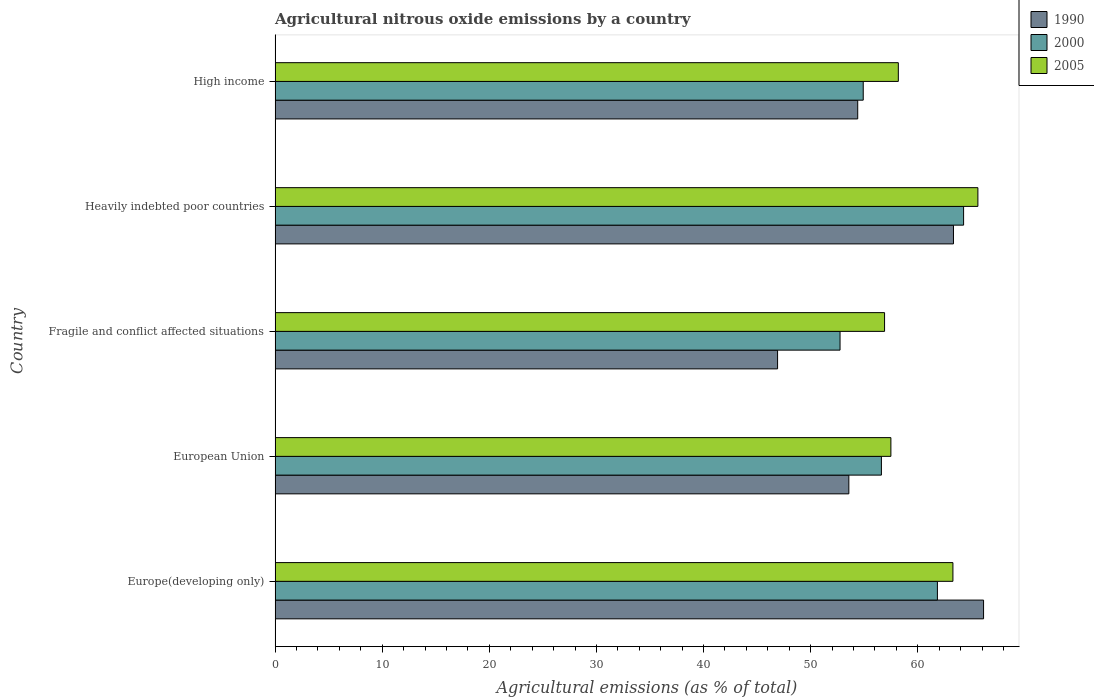Are the number of bars on each tick of the Y-axis equal?
Give a very brief answer. Yes. How many bars are there on the 1st tick from the bottom?
Make the answer very short. 3. What is the label of the 1st group of bars from the top?
Ensure brevity in your answer.  High income. What is the amount of agricultural nitrous oxide emitted in 2000 in Heavily indebted poor countries?
Keep it short and to the point. 64.27. Across all countries, what is the maximum amount of agricultural nitrous oxide emitted in 1990?
Provide a short and direct response. 66.14. Across all countries, what is the minimum amount of agricultural nitrous oxide emitted in 1990?
Offer a terse response. 46.91. In which country was the amount of agricultural nitrous oxide emitted in 2000 maximum?
Give a very brief answer. Heavily indebted poor countries. In which country was the amount of agricultural nitrous oxide emitted in 1990 minimum?
Offer a terse response. Fragile and conflict affected situations. What is the total amount of agricultural nitrous oxide emitted in 2000 in the graph?
Give a very brief answer. 290.35. What is the difference between the amount of agricultural nitrous oxide emitted in 1990 in European Union and that in Fragile and conflict affected situations?
Give a very brief answer. 6.65. What is the difference between the amount of agricultural nitrous oxide emitted in 2005 in Heavily indebted poor countries and the amount of agricultural nitrous oxide emitted in 2000 in Europe(developing only)?
Your answer should be very brief. 3.78. What is the average amount of agricultural nitrous oxide emitted in 2000 per country?
Provide a short and direct response. 58.07. What is the difference between the amount of agricultural nitrous oxide emitted in 2005 and amount of agricultural nitrous oxide emitted in 2000 in European Union?
Your answer should be compact. 0.89. What is the ratio of the amount of agricultural nitrous oxide emitted in 2005 in European Union to that in High income?
Keep it short and to the point. 0.99. Is the difference between the amount of agricultural nitrous oxide emitted in 2005 in European Union and High income greater than the difference between the amount of agricultural nitrous oxide emitted in 2000 in European Union and High income?
Provide a succinct answer. No. What is the difference between the highest and the second highest amount of agricultural nitrous oxide emitted in 2005?
Your answer should be very brief. 2.33. What is the difference between the highest and the lowest amount of agricultural nitrous oxide emitted in 1990?
Your response must be concise. 19.23. In how many countries, is the amount of agricultural nitrous oxide emitted in 2000 greater than the average amount of agricultural nitrous oxide emitted in 2000 taken over all countries?
Your answer should be compact. 2. Is the sum of the amount of agricultural nitrous oxide emitted in 2000 in Europe(developing only) and High income greater than the maximum amount of agricultural nitrous oxide emitted in 2005 across all countries?
Your response must be concise. Yes. What does the 1st bar from the top in Fragile and conflict affected situations represents?
Your answer should be very brief. 2005. Is it the case that in every country, the sum of the amount of agricultural nitrous oxide emitted in 2005 and amount of agricultural nitrous oxide emitted in 2000 is greater than the amount of agricultural nitrous oxide emitted in 1990?
Keep it short and to the point. Yes. Are all the bars in the graph horizontal?
Your answer should be very brief. Yes. Are the values on the major ticks of X-axis written in scientific E-notation?
Your answer should be very brief. No. Does the graph contain any zero values?
Provide a short and direct response. No. How many legend labels are there?
Your response must be concise. 3. What is the title of the graph?
Make the answer very short. Agricultural nitrous oxide emissions by a country. What is the label or title of the X-axis?
Your answer should be compact. Agricultural emissions (as % of total). What is the label or title of the Y-axis?
Make the answer very short. Country. What is the Agricultural emissions (as % of total) in 1990 in Europe(developing only)?
Provide a succinct answer. 66.14. What is the Agricultural emissions (as % of total) in 2000 in Europe(developing only)?
Give a very brief answer. 61.83. What is the Agricultural emissions (as % of total) of 2005 in Europe(developing only)?
Your response must be concise. 63.28. What is the Agricultural emissions (as % of total) of 1990 in European Union?
Keep it short and to the point. 53.56. What is the Agricultural emissions (as % of total) of 2000 in European Union?
Keep it short and to the point. 56.6. What is the Agricultural emissions (as % of total) in 2005 in European Union?
Your answer should be very brief. 57.49. What is the Agricultural emissions (as % of total) of 1990 in Fragile and conflict affected situations?
Provide a succinct answer. 46.91. What is the Agricultural emissions (as % of total) of 2000 in Fragile and conflict affected situations?
Ensure brevity in your answer.  52.74. What is the Agricultural emissions (as % of total) in 2005 in Fragile and conflict affected situations?
Your answer should be compact. 56.9. What is the Agricultural emissions (as % of total) in 1990 in Heavily indebted poor countries?
Provide a succinct answer. 63.33. What is the Agricultural emissions (as % of total) in 2000 in Heavily indebted poor countries?
Provide a succinct answer. 64.27. What is the Agricultural emissions (as % of total) of 2005 in Heavily indebted poor countries?
Keep it short and to the point. 65.61. What is the Agricultural emissions (as % of total) in 1990 in High income?
Offer a terse response. 54.39. What is the Agricultural emissions (as % of total) of 2000 in High income?
Make the answer very short. 54.91. What is the Agricultural emissions (as % of total) in 2005 in High income?
Ensure brevity in your answer.  58.18. Across all countries, what is the maximum Agricultural emissions (as % of total) of 1990?
Your response must be concise. 66.14. Across all countries, what is the maximum Agricultural emissions (as % of total) of 2000?
Provide a succinct answer. 64.27. Across all countries, what is the maximum Agricultural emissions (as % of total) in 2005?
Offer a very short reply. 65.61. Across all countries, what is the minimum Agricultural emissions (as % of total) of 1990?
Provide a short and direct response. 46.91. Across all countries, what is the minimum Agricultural emissions (as % of total) of 2000?
Ensure brevity in your answer.  52.74. Across all countries, what is the minimum Agricultural emissions (as % of total) of 2005?
Keep it short and to the point. 56.9. What is the total Agricultural emissions (as % of total) in 1990 in the graph?
Provide a short and direct response. 284.33. What is the total Agricultural emissions (as % of total) in 2000 in the graph?
Your response must be concise. 290.35. What is the total Agricultural emissions (as % of total) in 2005 in the graph?
Give a very brief answer. 301.45. What is the difference between the Agricultural emissions (as % of total) in 1990 in Europe(developing only) and that in European Union?
Offer a very short reply. 12.58. What is the difference between the Agricultural emissions (as % of total) in 2000 in Europe(developing only) and that in European Union?
Offer a very short reply. 5.23. What is the difference between the Agricultural emissions (as % of total) in 2005 in Europe(developing only) and that in European Union?
Your answer should be very brief. 5.79. What is the difference between the Agricultural emissions (as % of total) of 1990 in Europe(developing only) and that in Fragile and conflict affected situations?
Your answer should be very brief. 19.23. What is the difference between the Agricultural emissions (as % of total) in 2000 in Europe(developing only) and that in Fragile and conflict affected situations?
Provide a succinct answer. 9.09. What is the difference between the Agricultural emissions (as % of total) in 2005 in Europe(developing only) and that in Fragile and conflict affected situations?
Ensure brevity in your answer.  6.38. What is the difference between the Agricultural emissions (as % of total) of 1990 in Europe(developing only) and that in Heavily indebted poor countries?
Make the answer very short. 2.81. What is the difference between the Agricultural emissions (as % of total) of 2000 in Europe(developing only) and that in Heavily indebted poor countries?
Your answer should be very brief. -2.44. What is the difference between the Agricultural emissions (as % of total) of 2005 in Europe(developing only) and that in Heavily indebted poor countries?
Give a very brief answer. -2.33. What is the difference between the Agricultural emissions (as % of total) of 1990 in Europe(developing only) and that in High income?
Make the answer very short. 11.75. What is the difference between the Agricultural emissions (as % of total) in 2000 in Europe(developing only) and that in High income?
Your answer should be compact. 6.92. What is the difference between the Agricultural emissions (as % of total) in 2005 in Europe(developing only) and that in High income?
Give a very brief answer. 5.1. What is the difference between the Agricultural emissions (as % of total) of 1990 in European Union and that in Fragile and conflict affected situations?
Your answer should be very brief. 6.65. What is the difference between the Agricultural emissions (as % of total) of 2000 in European Union and that in Fragile and conflict affected situations?
Offer a very short reply. 3.86. What is the difference between the Agricultural emissions (as % of total) of 2005 in European Union and that in Fragile and conflict affected situations?
Ensure brevity in your answer.  0.59. What is the difference between the Agricultural emissions (as % of total) of 1990 in European Union and that in Heavily indebted poor countries?
Offer a terse response. -9.77. What is the difference between the Agricultural emissions (as % of total) of 2000 in European Union and that in Heavily indebted poor countries?
Make the answer very short. -7.67. What is the difference between the Agricultural emissions (as % of total) of 2005 in European Union and that in Heavily indebted poor countries?
Ensure brevity in your answer.  -8.12. What is the difference between the Agricultural emissions (as % of total) in 1990 in European Union and that in High income?
Provide a succinct answer. -0.83. What is the difference between the Agricultural emissions (as % of total) in 2000 in European Union and that in High income?
Keep it short and to the point. 1.7. What is the difference between the Agricultural emissions (as % of total) in 2005 in European Union and that in High income?
Your response must be concise. -0.69. What is the difference between the Agricultural emissions (as % of total) in 1990 in Fragile and conflict affected situations and that in Heavily indebted poor countries?
Your response must be concise. -16.42. What is the difference between the Agricultural emissions (as % of total) in 2000 in Fragile and conflict affected situations and that in Heavily indebted poor countries?
Provide a short and direct response. -11.53. What is the difference between the Agricultural emissions (as % of total) in 2005 in Fragile and conflict affected situations and that in Heavily indebted poor countries?
Keep it short and to the point. -8.71. What is the difference between the Agricultural emissions (as % of total) in 1990 in Fragile and conflict affected situations and that in High income?
Make the answer very short. -7.48. What is the difference between the Agricultural emissions (as % of total) in 2000 in Fragile and conflict affected situations and that in High income?
Offer a very short reply. -2.17. What is the difference between the Agricultural emissions (as % of total) of 2005 in Fragile and conflict affected situations and that in High income?
Make the answer very short. -1.28. What is the difference between the Agricultural emissions (as % of total) in 1990 in Heavily indebted poor countries and that in High income?
Your answer should be compact. 8.94. What is the difference between the Agricultural emissions (as % of total) in 2000 in Heavily indebted poor countries and that in High income?
Provide a short and direct response. 9.37. What is the difference between the Agricultural emissions (as % of total) in 2005 in Heavily indebted poor countries and that in High income?
Keep it short and to the point. 7.43. What is the difference between the Agricultural emissions (as % of total) of 1990 in Europe(developing only) and the Agricultural emissions (as % of total) of 2000 in European Union?
Keep it short and to the point. 9.54. What is the difference between the Agricultural emissions (as % of total) in 1990 in Europe(developing only) and the Agricultural emissions (as % of total) in 2005 in European Union?
Your response must be concise. 8.65. What is the difference between the Agricultural emissions (as % of total) of 2000 in Europe(developing only) and the Agricultural emissions (as % of total) of 2005 in European Union?
Keep it short and to the point. 4.34. What is the difference between the Agricultural emissions (as % of total) of 1990 in Europe(developing only) and the Agricultural emissions (as % of total) of 2000 in Fragile and conflict affected situations?
Your answer should be very brief. 13.4. What is the difference between the Agricultural emissions (as % of total) of 1990 in Europe(developing only) and the Agricultural emissions (as % of total) of 2005 in Fragile and conflict affected situations?
Ensure brevity in your answer.  9.24. What is the difference between the Agricultural emissions (as % of total) in 2000 in Europe(developing only) and the Agricultural emissions (as % of total) in 2005 in Fragile and conflict affected situations?
Keep it short and to the point. 4.93. What is the difference between the Agricultural emissions (as % of total) of 1990 in Europe(developing only) and the Agricultural emissions (as % of total) of 2000 in Heavily indebted poor countries?
Your answer should be compact. 1.86. What is the difference between the Agricultural emissions (as % of total) in 1990 in Europe(developing only) and the Agricultural emissions (as % of total) in 2005 in Heavily indebted poor countries?
Your answer should be compact. 0.53. What is the difference between the Agricultural emissions (as % of total) of 2000 in Europe(developing only) and the Agricultural emissions (as % of total) of 2005 in Heavily indebted poor countries?
Give a very brief answer. -3.78. What is the difference between the Agricultural emissions (as % of total) of 1990 in Europe(developing only) and the Agricultural emissions (as % of total) of 2000 in High income?
Offer a very short reply. 11.23. What is the difference between the Agricultural emissions (as % of total) of 1990 in Europe(developing only) and the Agricultural emissions (as % of total) of 2005 in High income?
Your response must be concise. 7.96. What is the difference between the Agricultural emissions (as % of total) in 2000 in Europe(developing only) and the Agricultural emissions (as % of total) in 2005 in High income?
Offer a terse response. 3.65. What is the difference between the Agricultural emissions (as % of total) of 1990 in European Union and the Agricultural emissions (as % of total) of 2000 in Fragile and conflict affected situations?
Your answer should be very brief. 0.82. What is the difference between the Agricultural emissions (as % of total) in 1990 in European Union and the Agricultural emissions (as % of total) in 2005 in Fragile and conflict affected situations?
Provide a short and direct response. -3.33. What is the difference between the Agricultural emissions (as % of total) in 2000 in European Union and the Agricultural emissions (as % of total) in 2005 in Fragile and conflict affected situations?
Ensure brevity in your answer.  -0.3. What is the difference between the Agricultural emissions (as % of total) in 1990 in European Union and the Agricultural emissions (as % of total) in 2000 in Heavily indebted poor countries?
Give a very brief answer. -10.71. What is the difference between the Agricultural emissions (as % of total) in 1990 in European Union and the Agricultural emissions (as % of total) in 2005 in Heavily indebted poor countries?
Your answer should be compact. -12.05. What is the difference between the Agricultural emissions (as % of total) of 2000 in European Union and the Agricultural emissions (as % of total) of 2005 in Heavily indebted poor countries?
Offer a terse response. -9.01. What is the difference between the Agricultural emissions (as % of total) of 1990 in European Union and the Agricultural emissions (as % of total) of 2000 in High income?
Give a very brief answer. -1.34. What is the difference between the Agricultural emissions (as % of total) in 1990 in European Union and the Agricultural emissions (as % of total) in 2005 in High income?
Ensure brevity in your answer.  -4.62. What is the difference between the Agricultural emissions (as % of total) of 2000 in European Union and the Agricultural emissions (as % of total) of 2005 in High income?
Make the answer very short. -1.58. What is the difference between the Agricultural emissions (as % of total) in 1990 in Fragile and conflict affected situations and the Agricultural emissions (as % of total) in 2000 in Heavily indebted poor countries?
Give a very brief answer. -17.36. What is the difference between the Agricultural emissions (as % of total) of 1990 in Fragile and conflict affected situations and the Agricultural emissions (as % of total) of 2005 in Heavily indebted poor countries?
Your response must be concise. -18.7. What is the difference between the Agricultural emissions (as % of total) in 2000 in Fragile and conflict affected situations and the Agricultural emissions (as % of total) in 2005 in Heavily indebted poor countries?
Keep it short and to the point. -12.87. What is the difference between the Agricultural emissions (as % of total) in 1990 in Fragile and conflict affected situations and the Agricultural emissions (as % of total) in 2000 in High income?
Provide a short and direct response. -8. What is the difference between the Agricultural emissions (as % of total) of 1990 in Fragile and conflict affected situations and the Agricultural emissions (as % of total) of 2005 in High income?
Ensure brevity in your answer.  -11.27. What is the difference between the Agricultural emissions (as % of total) in 2000 in Fragile and conflict affected situations and the Agricultural emissions (as % of total) in 2005 in High income?
Offer a terse response. -5.44. What is the difference between the Agricultural emissions (as % of total) in 1990 in Heavily indebted poor countries and the Agricultural emissions (as % of total) in 2000 in High income?
Provide a short and direct response. 8.42. What is the difference between the Agricultural emissions (as % of total) in 1990 in Heavily indebted poor countries and the Agricultural emissions (as % of total) in 2005 in High income?
Keep it short and to the point. 5.15. What is the difference between the Agricultural emissions (as % of total) in 2000 in Heavily indebted poor countries and the Agricultural emissions (as % of total) in 2005 in High income?
Make the answer very short. 6.09. What is the average Agricultural emissions (as % of total) in 1990 per country?
Offer a terse response. 56.87. What is the average Agricultural emissions (as % of total) of 2000 per country?
Give a very brief answer. 58.07. What is the average Agricultural emissions (as % of total) in 2005 per country?
Give a very brief answer. 60.29. What is the difference between the Agricultural emissions (as % of total) in 1990 and Agricultural emissions (as % of total) in 2000 in Europe(developing only)?
Ensure brevity in your answer.  4.31. What is the difference between the Agricultural emissions (as % of total) in 1990 and Agricultural emissions (as % of total) in 2005 in Europe(developing only)?
Offer a terse response. 2.86. What is the difference between the Agricultural emissions (as % of total) in 2000 and Agricultural emissions (as % of total) in 2005 in Europe(developing only)?
Your response must be concise. -1.45. What is the difference between the Agricultural emissions (as % of total) of 1990 and Agricultural emissions (as % of total) of 2000 in European Union?
Your answer should be compact. -3.04. What is the difference between the Agricultural emissions (as % of total) in 1990 and Agricultural emissions (as % of total) in 2005 in European Union?
Your response must be concise. -3.92. What is the difference between the Agricultural emissions (as % of total) in 2000 and Agricultural emissions (as % of total) in 2005 in European Union?
Offer a terse response. -0.89. What is the difference between the Agricultural emissions (as % of total) in 1990 and Agricultural emissions (as % of total) in 2000 in Fragile and conflict affected situations?
Make the answer very short. -5.83. What is the difference between the Agricultural emissions (as % of total) in 1990 and Agricultural emissions (as % of total) in 2005 in Fragile and conflict affected situations?
Ensure brevity in your answer.  -9.99. What is the difference between the Agricultural emissions (as % of total) in 2000 and Agricultural emissions (as % of total) in 2005 in Fragile and conflict affected situations?
Make the answer very short. -4.16. What is the difference between the Agricultural emissions (as % of total) in 1990 and Agricultural emissions (as % of total) in 2000 in Heavily indebted poor countries?
Give a very brief answer. -0.94. What is the difference between the Agricultural emissions (as % of total) in 1990 and Agricultural emissions (as % of total) in 2005 in Heavily indebted poor countries?
Ensure brevity in your answer.  -2.28. What is the difference between the Agricultural emissions (as % of total) in 2000 and Agricultural emissions (as % of total) in 2005 in Heavily indebted poor countries?
Give a very brief answer. -1.33. What is the difference between the Agricultural emissions (as % of total) of 1990 and Agricultural emissions (as % of total) of 2000 in High income?
Ensure brevity in your answer.  -0.52. What is the difference between the Agricultural emissions (as % of total) of 1990 and Agricultural emissions (as % of total) of 2005 in High income?
Provide a short and direct response. -3.79. What is the difference between the Agricultural emissions (as % of total) in 2000 and Agricultural emissions (as % of total) in 2005 in High income?
Your response must be concise. -3.28. What is the ratio of the Agricultural emissions (as % of total) of 1990 in Europe(developing only) to that in European Union?
Your response must be concise. 1.23. What is the ratio of the Agricultural emissions (as % of total) in 2000 in Europe(developing only) to that in European Union?
Give a very brief answer. 1.09. What is the ratio of the Agricultural emissions (as % of total) of 2005 in Europe(developing only) to that in European Union?
Your response must be concise. 1.1. What is the ratio of the Agricultural emissions (as % of total) of 1990 in Europe(developing only) to that in Fragile and conflict affected situations?
Make the answer very short. 1.41. What is the ratio of the Agricultural emissions (as % of total) of 2000 in Europe(developing only) to that in Fragile and conflict affected situations?
Offer a very short reply. 1.17. What is the ratio of the Agricultural emissions (as % of total) of 2005 in Europe(developing only) to that in Fragile and conflict affected situations?
Offer a very short reply. 1.11. What is the ratio of the Agricultural emissions (as % of total) in 1990 in Europe(developing only) to that in Heavily indebted poor countries?
Provide a short and direct response. 1.04. What is the ratio of the Agricultural emissions (as % of total) of 2005 in Europe(developing only) to that in Heavily indebted poor countries?
Your answer should be very brief. 0.96. What is the ratio of the Agricultural emissions (as % of total) in 1990 in Europe(developing only) to that in High income?
Give a very brief answer. 1.22. What is the ratio of the Agricultural emissions (as % of total) of 2000 in Europe(developing only) to that in High income?
Ensure brevity in your answer.  1.13. What is the ratio of the Agricultural emissions (as % of total) of 2005 in Europe(developing only) to that in High income?
Your response must be concise. 1.09. What is the ratio of the Agricultural emissions (as % of total) in 1990 in European Union to that in Fragile and conflict affected situations?
Offer a very short reply. 1.14. What is the ratio of the Agricultural emissions (as % of total) in 2000 in European Union to that in Fragile and conflict affected situations?
Your response must be concise. 1.07. What is the ratio of the Agricultural emissions (as % of total) of 2005 in European Union to that in Fragile and conflict affected situations?
Ensure brevity in your answer.  1.01. What is the ratio of the Agricultural emissions (as % of total) in 1990 in European Union to that in Heavily indebted poor countries?
Provide a succinct answer. 0.85. What is the ratio of the Agricultural emissions (as % of total) of 2000 in European Union to that in Heavily indebted poor countries?
Offer a very short reply. 0.88. What is the ratio of the Agricultural emissions (as % of total) of 2005 in European Union to that in Heavily indebted poor countries?
Provide a short and direct response. 0.88. What is the ratio of the Agricultural emissions (as % of total) of 1990 in European Union to that in High income?
Ensure brevity in your answer.  0.98. What is the ratio of the Agricultural emissions (as % of total) in 2000 in European Union to that in High income?
Make the answer very short. 1.03. What is the ratio of the Agricultural emissions (as % of total) in 1990 in Fragile and conflict affected situations to that in Heavily indebted poor countries?
Provide a short and direct response. 0.74. What is the ratio of the Agricultural emissions (as % of total) of 2000 in Fragile and conflict affected situations to that in Heavily indebted poor countries?
Your answer should be very brief. 0.82. What is the ratio of the Agricultural emissions (as % of total) of 2005 in Fragile and conflict affected situations to that in Heavily indebted poor countries?
Give a very brief answer. 0.87. What is the ratio of the Agricultural emissions (as % of total) in 1990 in Fragile and conflict affected situations to that in High income?
Offer a terse response. 0.86. What is the ratio of the Agricultural emissions (as % of total) in 2000 in Fragile and conflict affected situations to that in High income?
Offer a very short reply. 0.96. What is the ratio of the Agricultural emissions (as % of total) of 2005 in Fragile and conflict affected situations to that in High income?
Offer a very short reply. 0.98. What is the ratio of the Agricultural emissions (as % of total) of 1990 in Heavily indebted poor countries to that in High income?
Your answer should be compact. 1.16. What is the ratio of the Agricultural emissions (as % of total) of 2000 in Heavily indebted poor countries to that in High income?
Your response must be concise. 1.17. What is the ratio of the Agricultural emissions (as % of total) in 2005 in Heavily indebted poor countries to that in High income?
Make the answer very short. 1.13. What is the difference between the highest and the second highest Agricultural emissions (as % of total) in 1990?
Give a very brief answer. 2.81. What is the difference between the highest and the second highest Agricultural emissions (as % of total) in 2000?
Your response must be concise. 2.44. What is the difference between the highest and the second highest Agricultural emissions (as % of total) of 2005?
Give a very brief answer. 2.33. What is the difference between the highest and the lowest Agricultural emissions (as % of total) of 1990?
Ensure brevity in your answer.  19.23. What is the difference between the highest and the lowest Agricultural emissions (as % of total) of 2000?
Your response must be concise. 11.53. What is the difference between the highest and the lowest Agricultural emissions (as % of total) in 2005?
Your response must be concise. 8.71. 